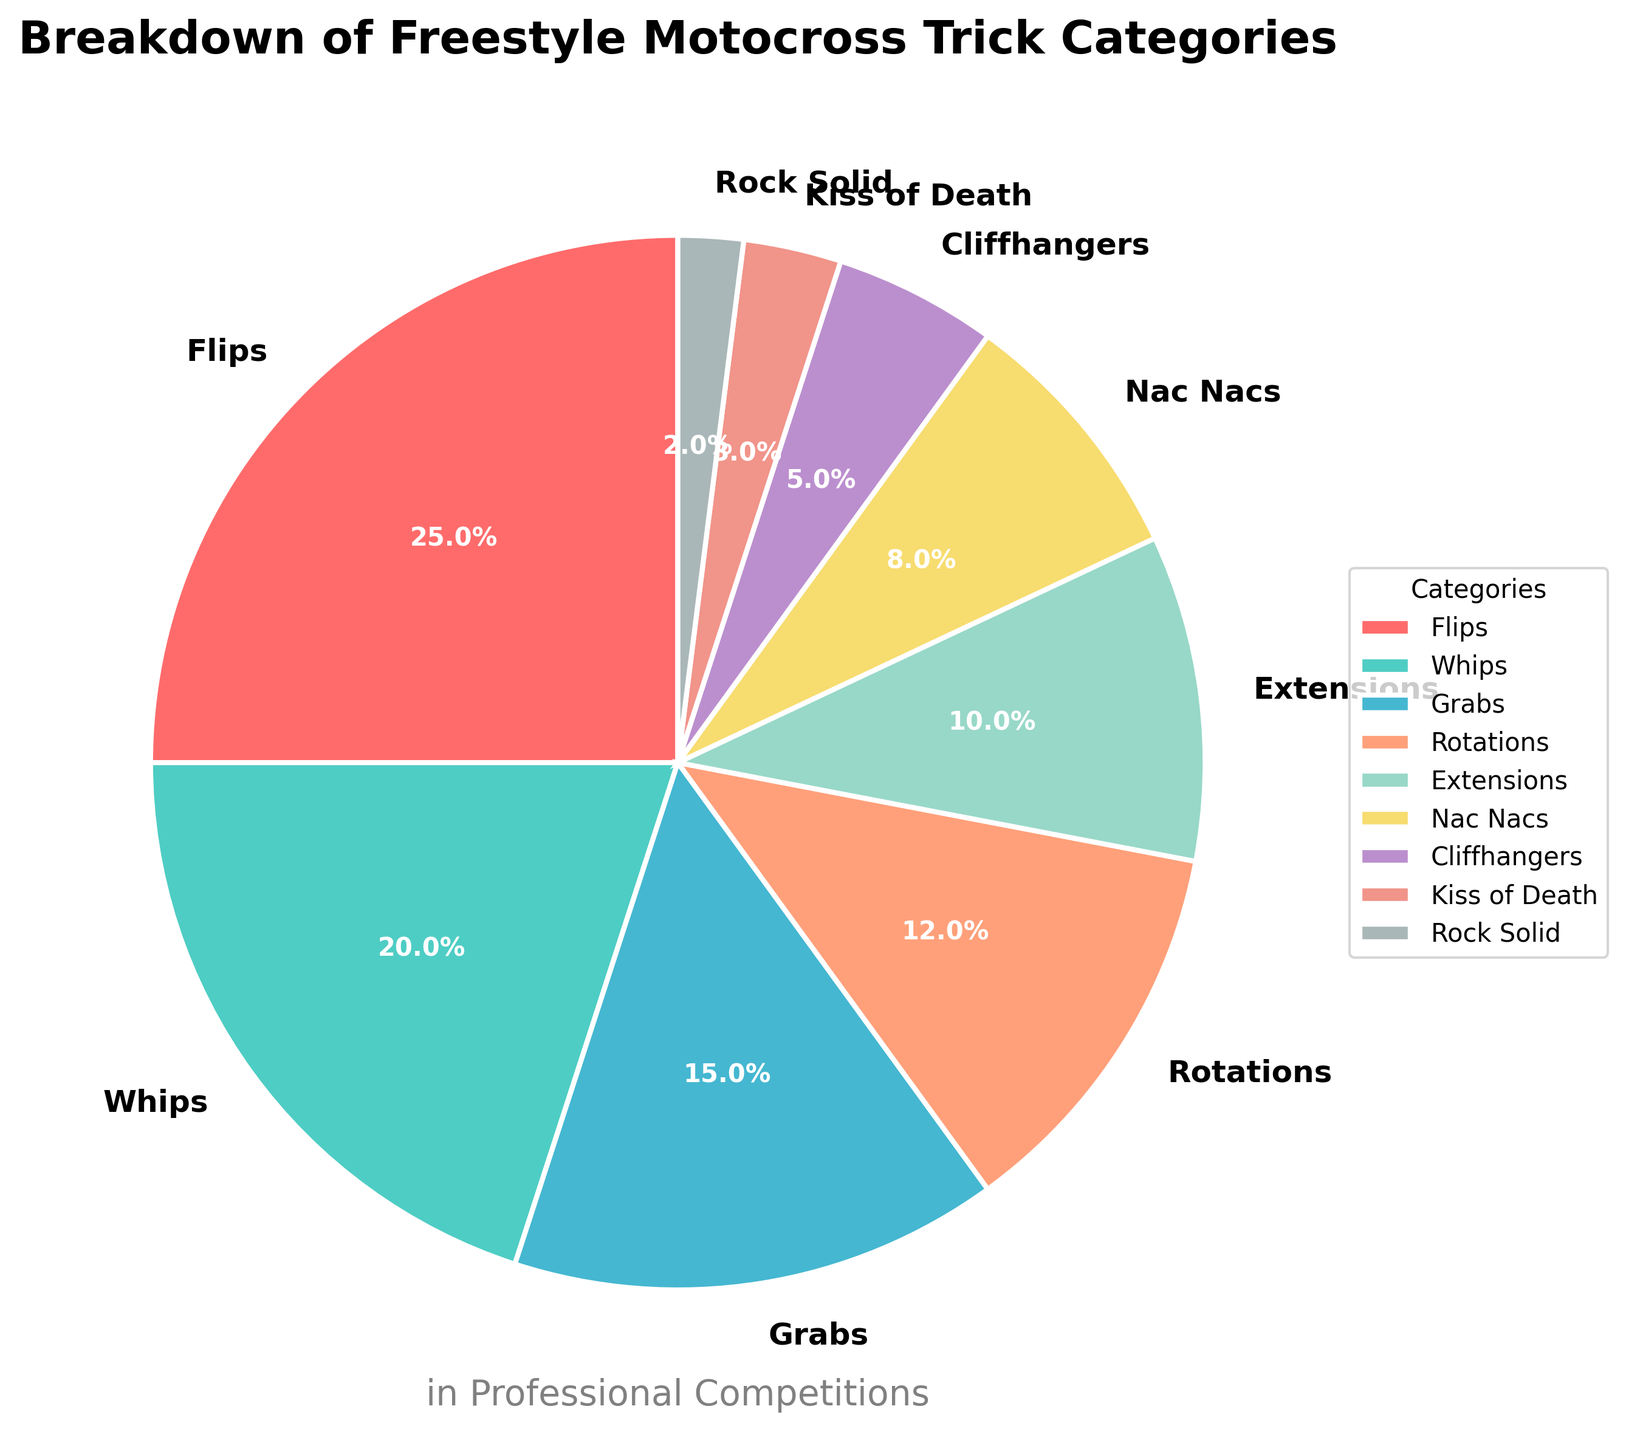Which category has the highest percentage? The largest segment in the pie chart corresponds to the category labeled 'Flips'.
Answer: Flips What is the difference in percentage between 'Whips' and 'Grabs'? The percentage for 'Whips' is 20% and for 'Grabs' is 15%. The difference is calculated as 20% - 15% = 5%.
Answer: 5% How much in total do 'Rotations', 'Extensions', and 'Nac Nacs' account for? The percentages are as follows: Rotations (12%), Extensions (10%), and Nac Nacs (8%). Sum these values: 12% + 10% + 8% = 30%.
Answer: 30% Which two categories combined have the lowest percentage? 'Rock Solid' has 2% and 'Kiss of Death' has 3%. Together they sum to 2% + 3% = 5%. This is the lowest combined percentage among all possible pairs of categories.
Answer: Rock Solid and Kiss of Death What is the percentage difference between 'Cliffhangers' and 'Nac Nacs'? The percentage for 'Cliffhangers' is 5% and for 'Nac Nacs' is 8%. The difference is calculated as 8% - 5% = 3%.
Answer: 3% Which category is represented by the light blue segment? According to the provided code, light blue corresponds to the second item in the custom colors list, which is assigned to 'Whips' based on their order.
Answer: Whips Are there more 'Grabs' or 'Extensions' tricks, and by what percentage? 'Grabs' account for 15% and 'Extensions' account for 10%. The difference is 15% - 10% = 5%. This means there are 5% more 'Grabs' than 'Extensions'.
Answer: Grabs, 5% What percentage of tricks fall under 'Cliffhangers' and 'Kiss of Death' combined? The percentages for 'Cliffhangers' and 'Kiss of Death' are 5% and 3%, respectively. Summing these gives 5% + 3% = 8%.
Answer: 8% Which category is represented by the smallest segment and by what percentage? The smallest segment in the pie chart corresponds to 'Rock Solid', which accounts for 2%.
Answer: Rock Solid, 2% If 'Flips' and 'Whips' are performed together, what percentage of the total do they represent? The percentage for 'Flips' is 25% and for 'Whips' is 20%. Together they represent 25% + 20% = 45%.
Answer: 45% 